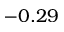Convert formula to latex. <formula><loc_0><loc_0><loc_500><loc_500>- 0 . 2 9</formula> 